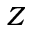<formula> <loc_0><loc_0><loc_500><loc_500>Z</formula> 